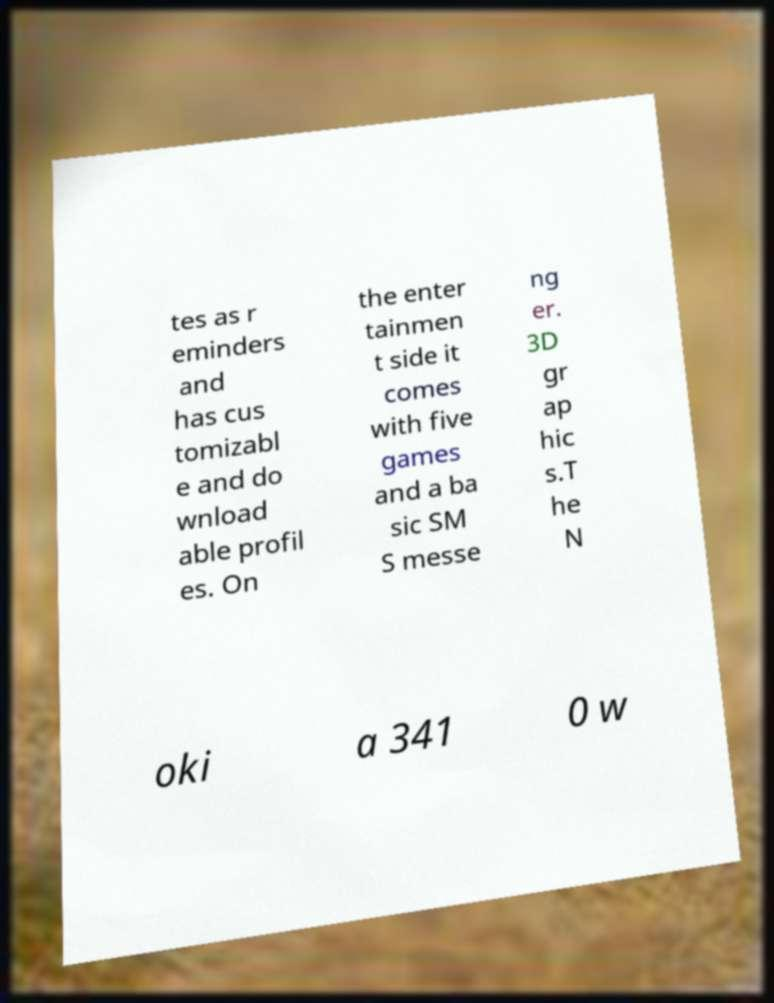I need the written content from this picture converted into text. Can you do that? tes as r eminders and has cus tomizabl e and do wnload able profil es. On the enter tainmen t side it comes with five games and a ba sic SM S messe ng er. 3D gr ap hic s.T he N oki a 341 0 w 